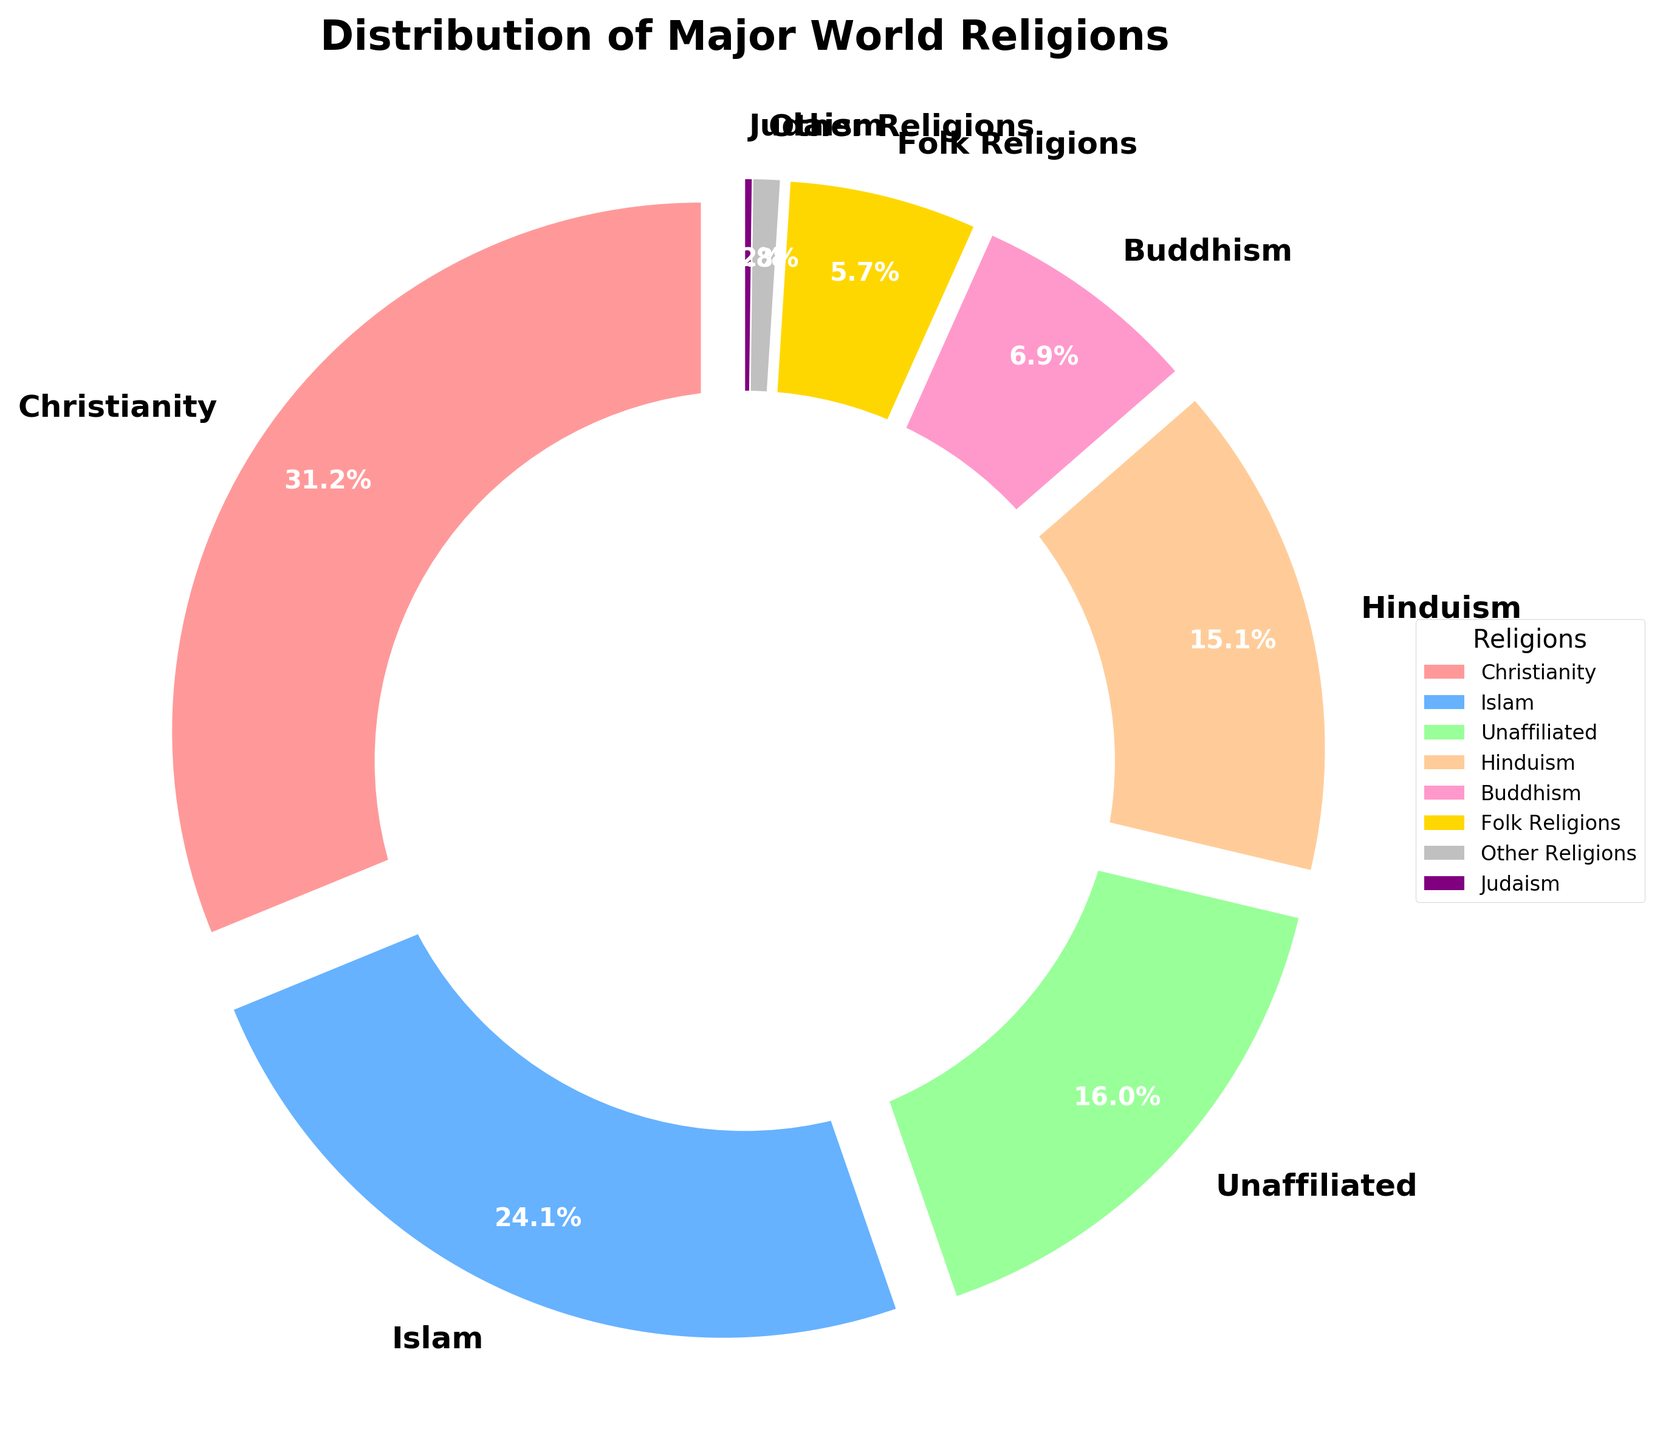What percentage of the global population follows Christianity? The chart shows the percentage distribution for each religion. The label for Christianity shows 31.2%.
Answer: 31.2% Which religion has the second-largest following worldwide? By examining the pie chart, the religion with the second-largest slice after Christianity is Islam, labeled with 24.1%.
Answer: Islam What is the combined percentage of people who follow Hinduism and Buddhism? The chart shows Hinduism with 15.1% and Buddhism with 6.9%. Summing them up gives 15.1% + 6.9% = 22.0%.
Answer: 22.0% Are there more unaffiliated individuals than Buddhists? The pie chart shows 16.0% for Unaffiliated and 6.9% for Buddhism. Since 16.0% > 6.9%, there are more unaffiliated individuals.
Answer: Yes What is the smallest religion represented in the chart and its percentage? The pie chart shows Judaism as the smallest segment, labeled with 0.2%.
Answer: Judaism, 0.2% Which two religions combined have a percentage closest to that of Islam? To find which two percentages combined are closest to 24.1%, we can see that Hinduism (15.1%) and Buddhism (6.9%) together add up to 22.0%. This is the closest combined percentage to 24.1%.
Answer: Hinduism and Buddhism Compare Christianity and Folk Religions. What is the difference in their percentages? Christianity has 31.2% and Folk Religions have 5.7%. The difference is 31.2% - 5.7% = 25.5%.
Answer: 25.5% What is the total percentage of religions apart from Christianity and Islam? Removing Christianity (31.2%) and Islam (24.1%) from the total 100% leaves us: 100% - 31.2% - 24.1% = 44.7%.
Answer: 44.7% What is the percentage difference between the third most followed religion and the fourth? Unaffiliated is third with 16.0% and Hinduism is fourth with 15.1%. The difference is 16.0% - 15.1% = 0.9%.
Answer: 0.9% 